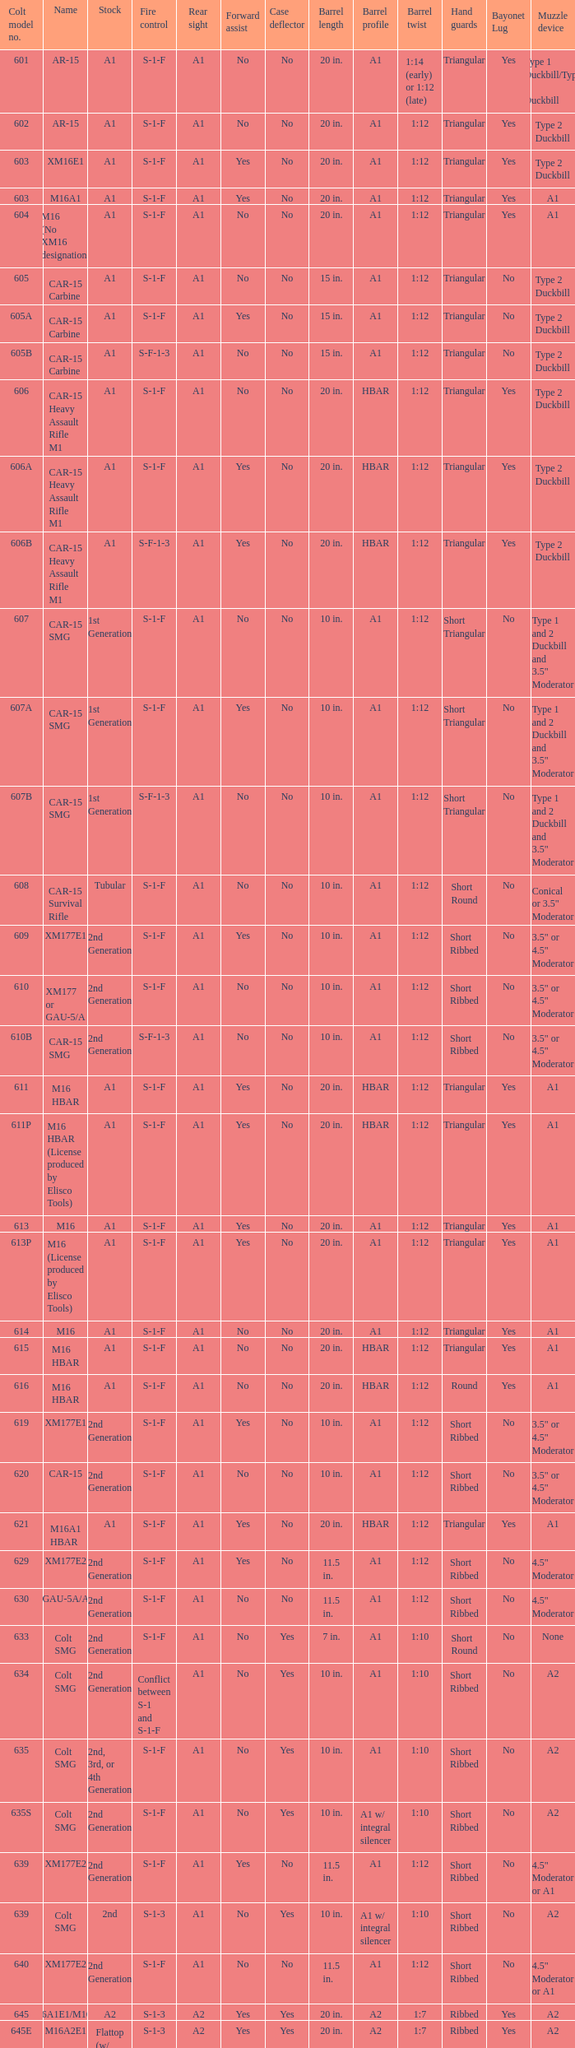What are the colt model numbers for the versions called gau-5a/a, which have no bayonet lug, no case deflector, and a 2nd generation stock? 630, 649. 